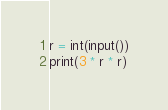Convert code to text. <code><loc_0><loc_0><loc_500><loc_500><_Python_>r = int(input())
print(3 * r * r)</code> 